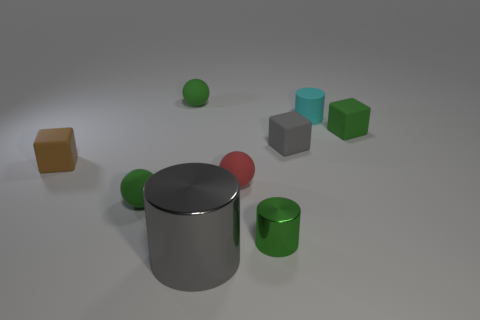Add 1 large yellow balls. How many objects exist? 10 Subtract all cubes. How many objects are left? 6 Subtract 1 green cylinders. How many objects are left? 8 Subtract all blue blocks. Subtract all tiny green objects. How many objects are left? 5 Add 3 tiny red things. How many tiny red things are left? 4 Add 6 yellow metallic cylinders. How many yellow metallic cylinders exist? 6 